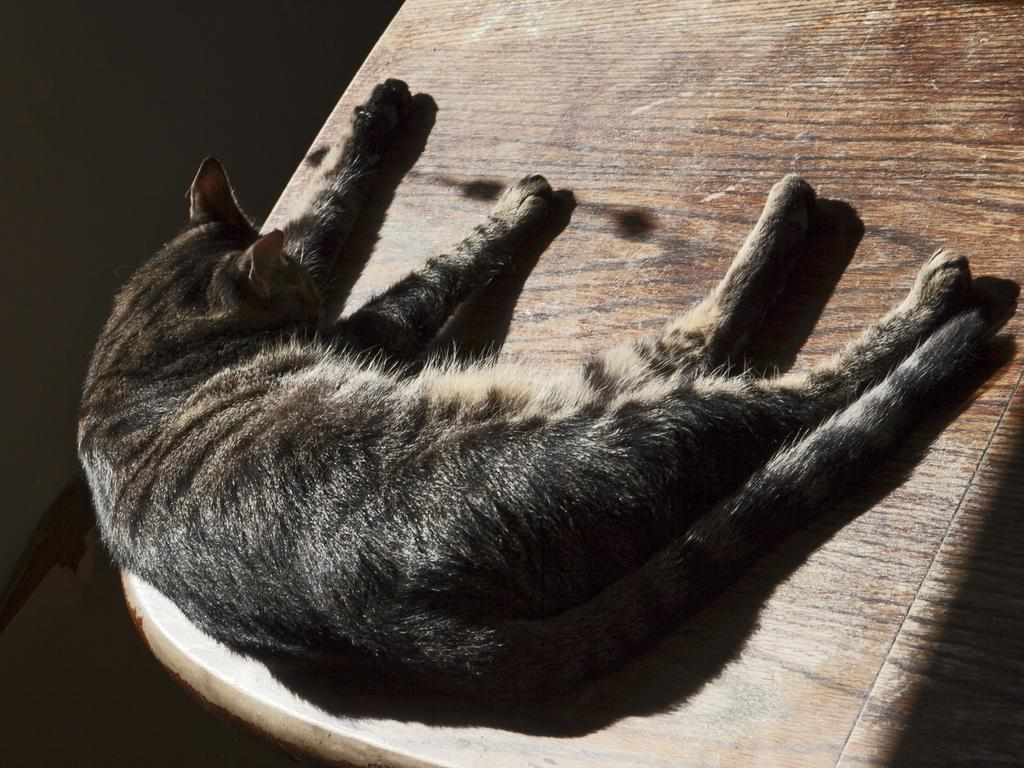What type of animal is in the image? There is a cat in the image. What is the cat doing in the image? The cat is sleeping. On what surface is the cat resting? The cat is on a wooden surface. What type of appliance is the cat using in the image? There is no appliance present in the image; the cat is simply sleeping on a wooden surface. 